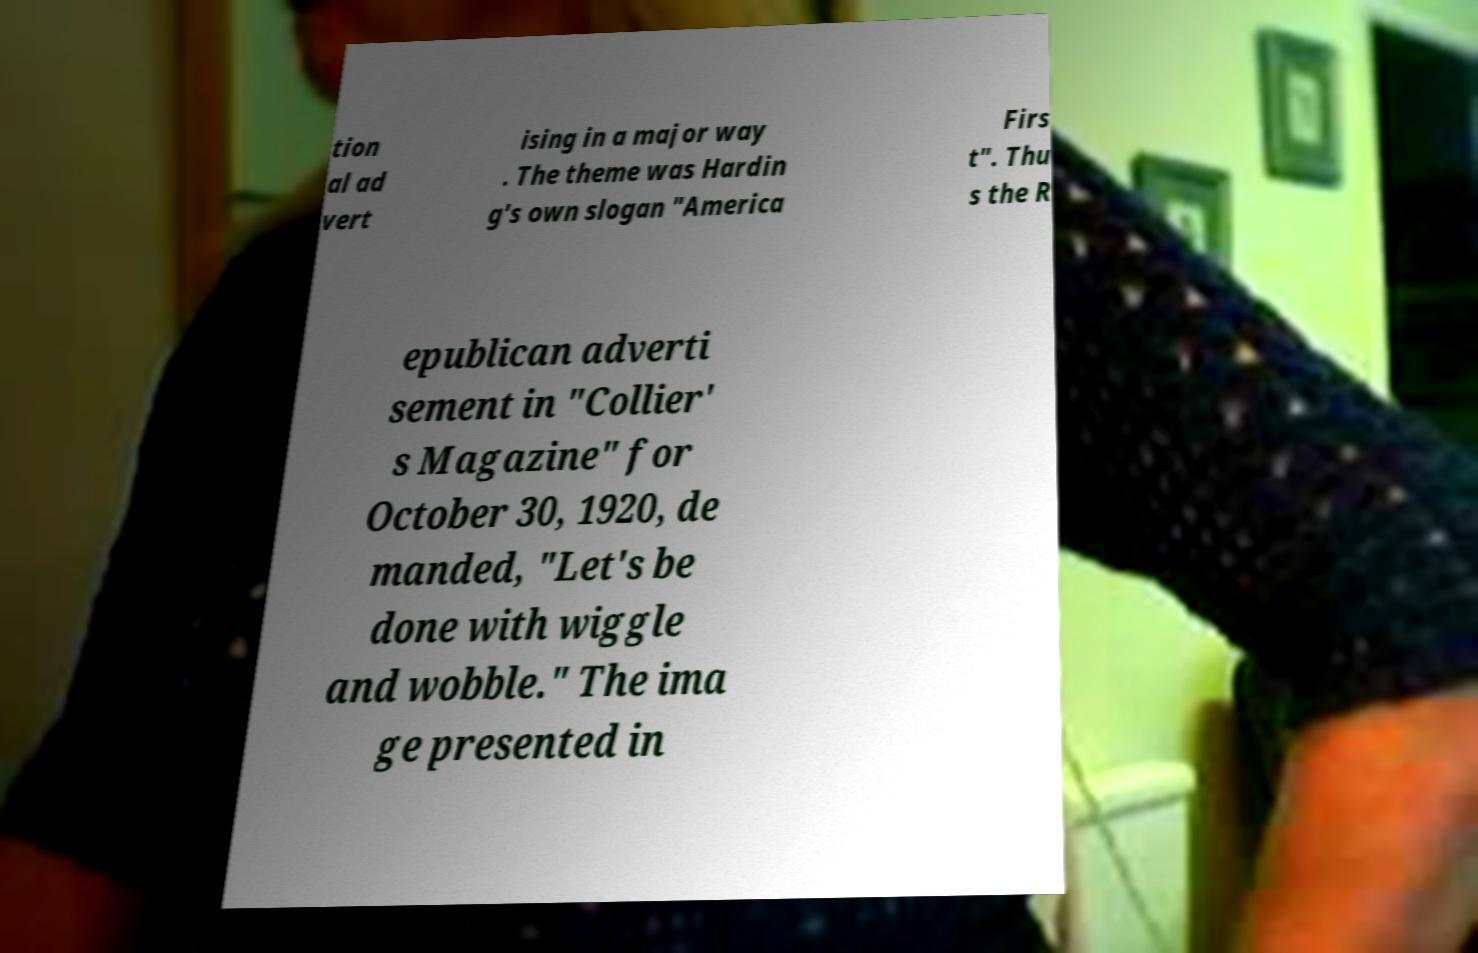What messages or text are displayed in this image? I need them in a readable, typed format. tion al ad vert ising in a major way . The theme was Hardin g's own slogan "America Firs t". Thu s the R epublican adverti sement in "Collier' s Magazine" for October 30, 1920, de manded, "Let's be done with wiggle and wobble." The ima ge presented in 